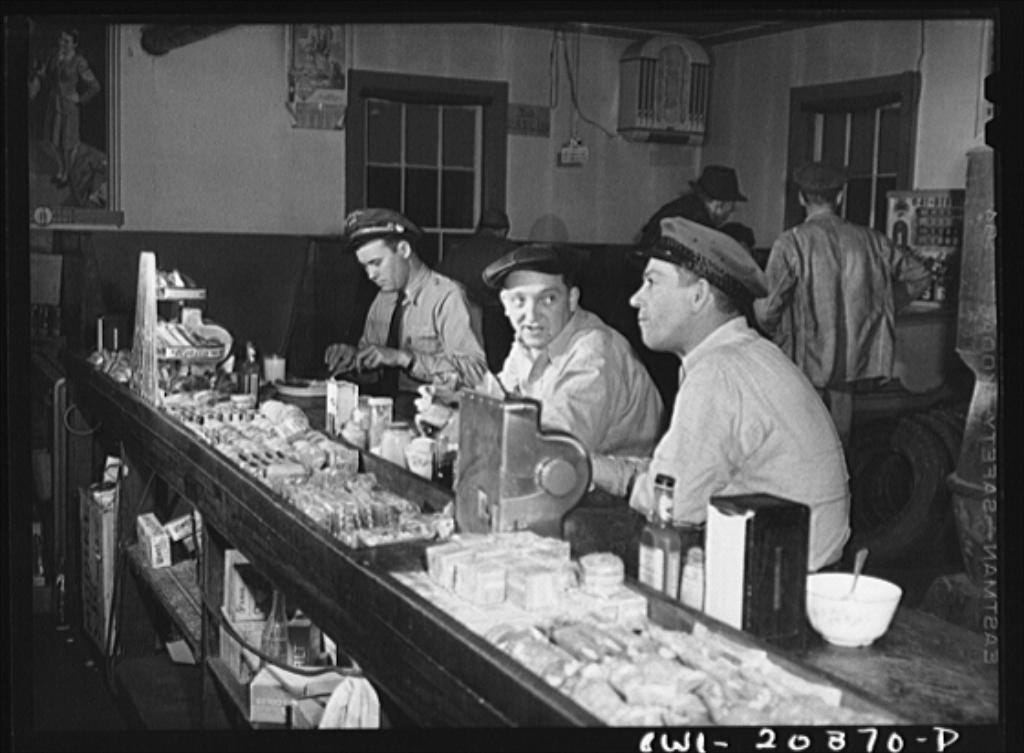Describe this image in one or two sentences. In this picture I can see people among them three people are sitting in front of table. On the table I can see bottles, bowls and some other objects. In the background I can see windows, photos and other objects on the wall. This picture is black and white in color. 